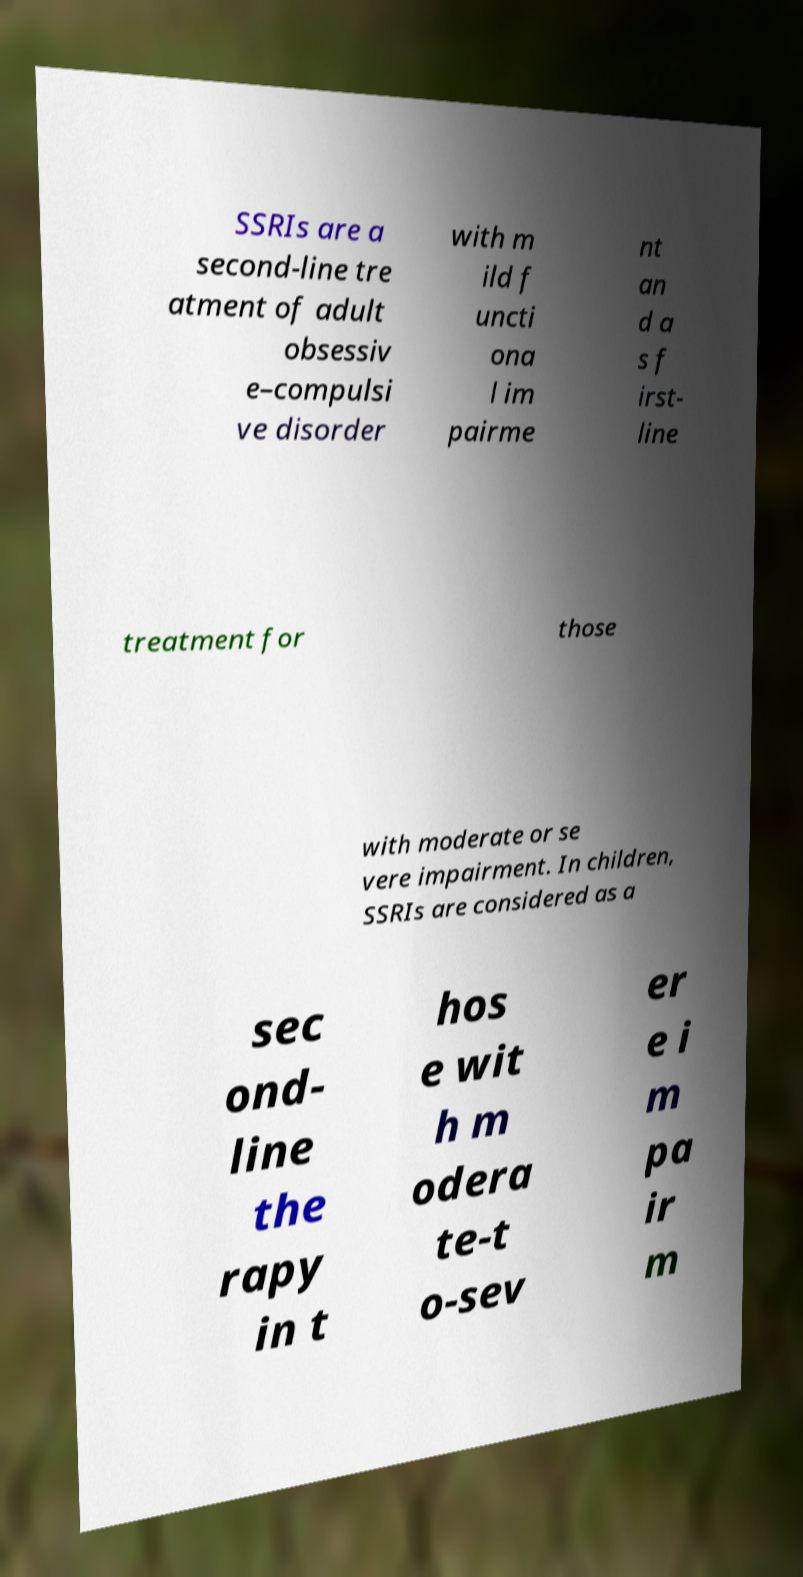Could you assist in decoding the text presented in this image and type it out clearly? SSRIs are a second-line tre atment of adult obsessiv e–compulsi ve disorder with m ild f uncti ona l im pairme nt an d a s f irst- line treatment for those with moderate or se vere impairment. In children, SSRIs are considered as a sec ond- line the rapy in t hos e wit h m odera te-t o-sev er e i m pa ir m 